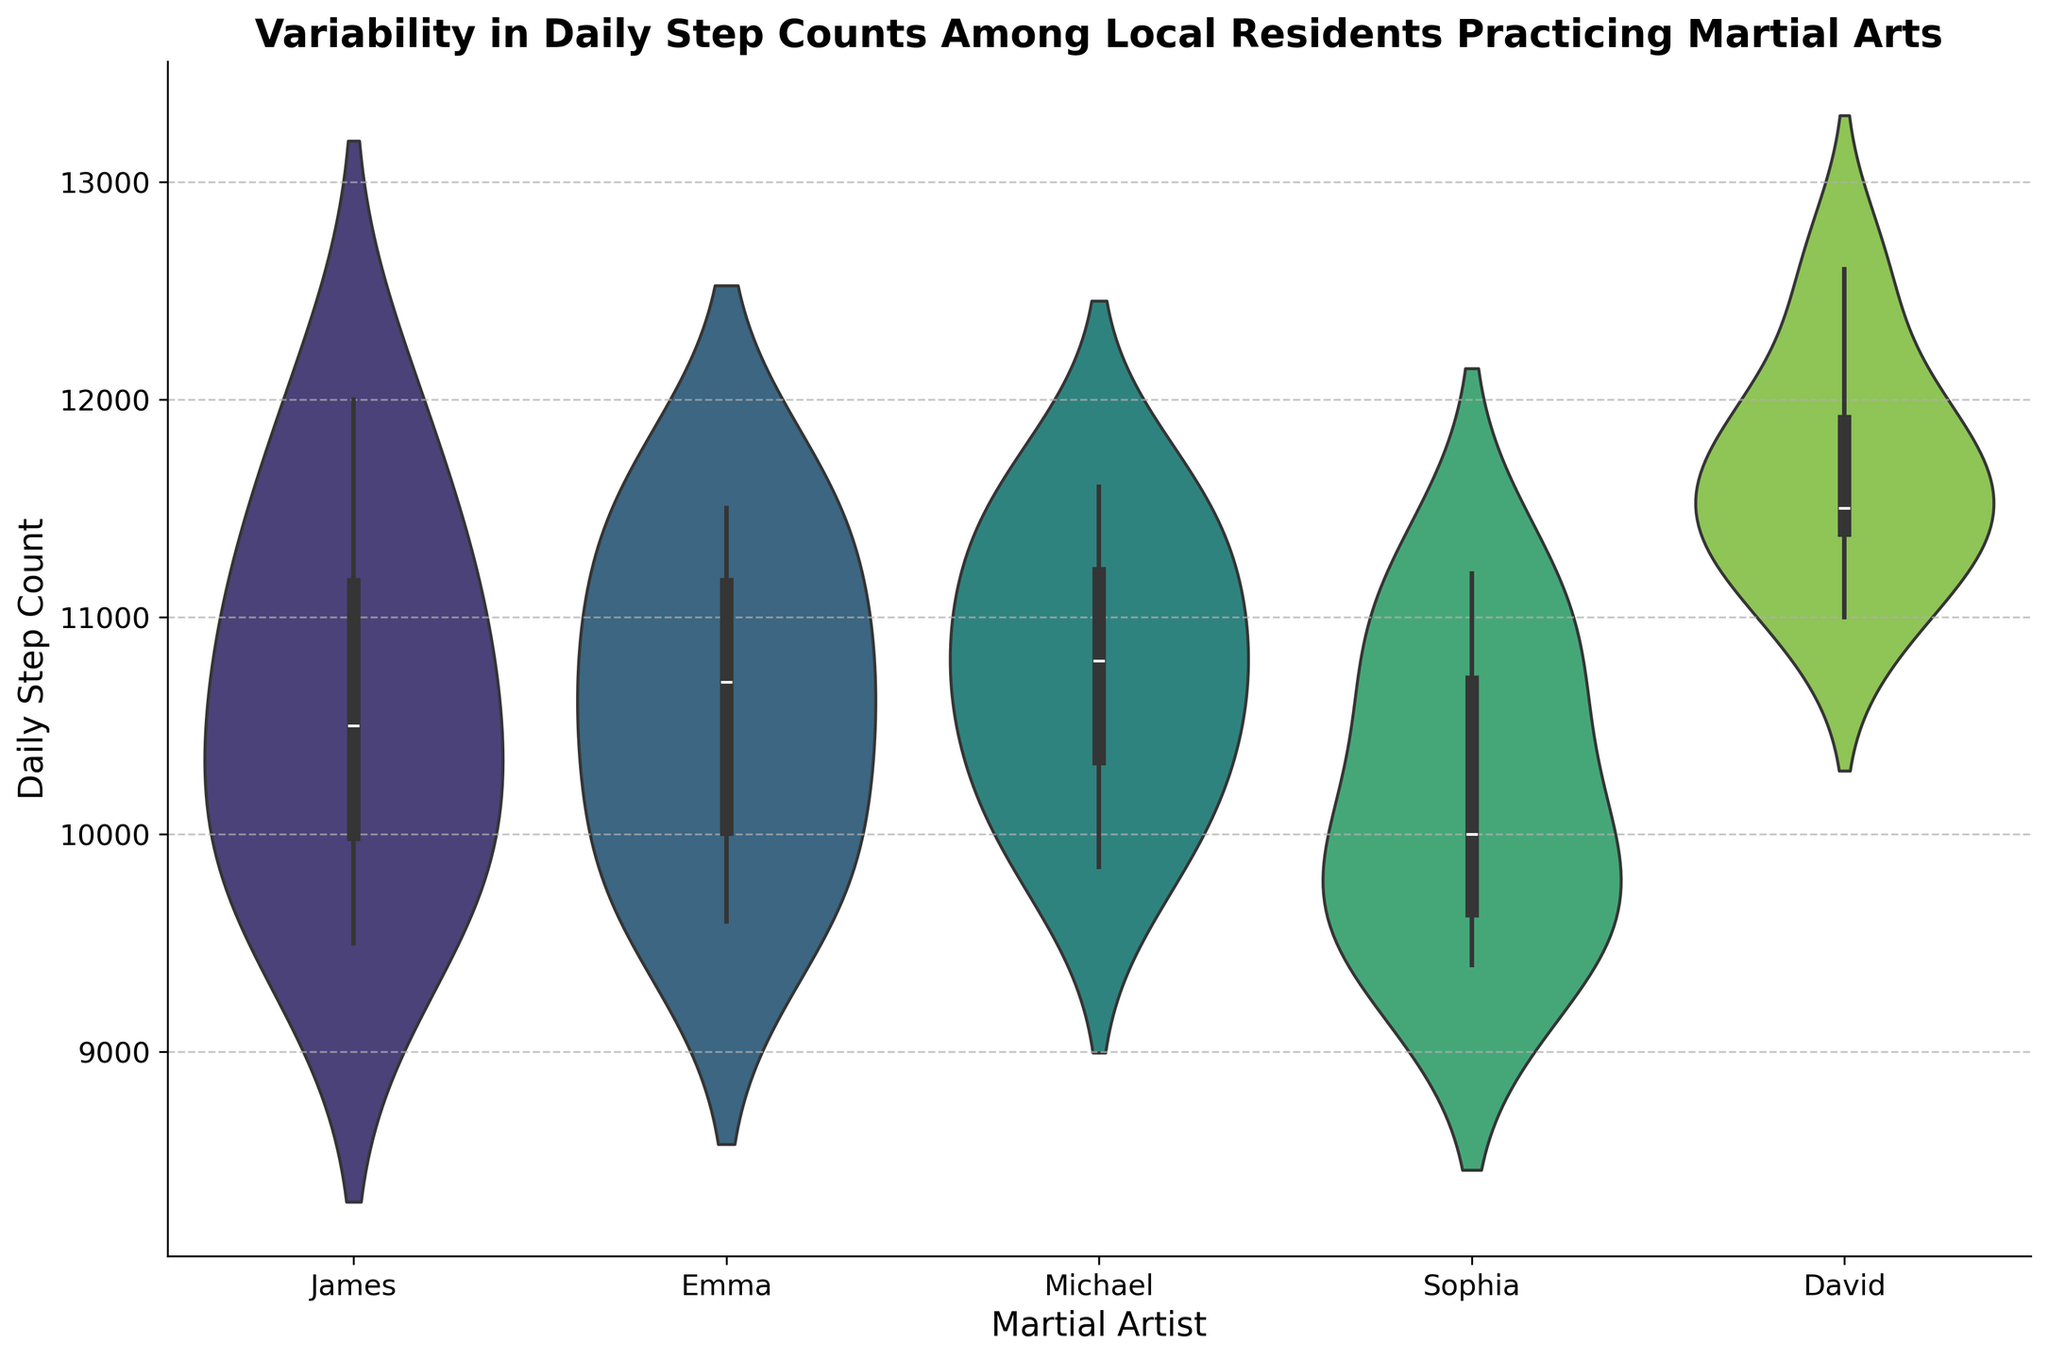what is the title of the figure? The title of the figure is displayed at the top and provides the main topic or insight of the chart. In this case, it reads "Variability in Daily Step Counts Among Local Residents Practicing Martial Arts"
Answer: Variability in Daily Step Counts Among Local Residents Practicing Martial Arts Which martial artist has the widest range of daily step counts? To identify the martial artist with the widest range of step counts, we need to look at the upper and lower extremes of each violin plot and see which one spans the greatest distance.
Answer: David What is the median daily step count for Sophia? The median value of the daily step count is indicated by the central line within the box plot overlaid on the violin plot for Sophia.
Answer: 10,000 Who has the highest median daily step count among the martial artists? To find the highest median daily step count, we compare the central lines within the box plots for each martial artist. The martial artist with the highest central line has the highest median.
Answer: David How do James and Emma's daily step counts compare in terms of variability? By examining the width and spread of their violin plots, we can determine how variable their daily step counts are. A wider and more dispersed plot indicates greater variability.
Answer: James has more variability than Emma Which martial artists have interquartile ranges overlapping with David? The interquartile range (middle 50% of data) is shown by the box in the box plot. We need to compare these boxes for each martial artist and see which ones overlap with David's interquartile range.
Answer: James, Michael, Emma What is the approximate maximum daily step count for Michael? The maximum daily step count for Michael is indicated by the uppermost point of the violin plot for him.
Answer: 11,600 Which martial artist has the smallest interquartile range? The smallest interquartile range is indicated by the narrowest box in the box plot section of the violin plot.
Answer: Emma Is there any martial artist with a median daily step count below 10,000? To answer this, we need to look at the median lines within the box plots and check if any of them fall below the 10,000 mark.
Answer: No Which martial artist's data shows more symmetry around the median, indicating a normal distribution? A symmetric violin plot around the median line suggests a more normally distributed data set.
Answer: Michael 